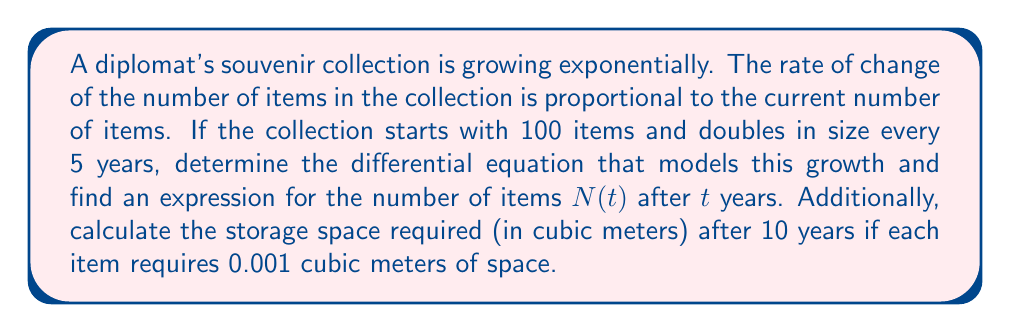Could you help me with this problem? Let's approach this problem step-by-step:

1) First, we need to set up the differential equation. The rate of change is proportional to the current number of items:

   $$\frac{dN}{dt} = kN$$

   where $k$ is the growth constant.

2) We're told that the collection doubles every 5 years. We can use this to find $k$:

   $$N(5) = 2N(0)$$
   $$100e^{5k} = 2(100)$$
   $$e^{5k} = 2$$
   $$5k = \ln(2)$$
   $$k = \frac{\ln(2)}{5} \approx 0.1386$$

3) Now we have our complete differential equation:

   $$\frac{dN}{dt} = \frac{\ln(2)}{5}N$$

4) The general solution to this equation is:

   $$N(t) = Ce^{\frac{\ln(2)}{5}t}$$

   where $C$ is a constant we can determine from the initial condition.

5) We know that $N(0) = 100$, so:

   $$100 = Ce^{\frac{\ln(2)}{5}(0)}$$
   $$100 = C$$

6) Therefore, our specific solution is:

   $$N(t) = 100e^{\frac{\ln(2)}{5}t}$$

7) To find the number of items after 10 years:

   $$N(10) = 100e^{\frac{\ln(2)}{5}(10)} \approx 400$$

8) Each item requires 0.001 cubic meters, so the total space required is:

   $$400 * 0.001 = 0.4$$ cubic meters
Answer: The differential equation modeling the growth is $\frac{dN}{dt} = \frac{\ln(2)}{5}N$. The number of items after $t$ years is given by $N(t) = 100e^{\frac{\ln(2)}{5}t}$. After 10 years, the storage space required is 0.4 cubic meters. 